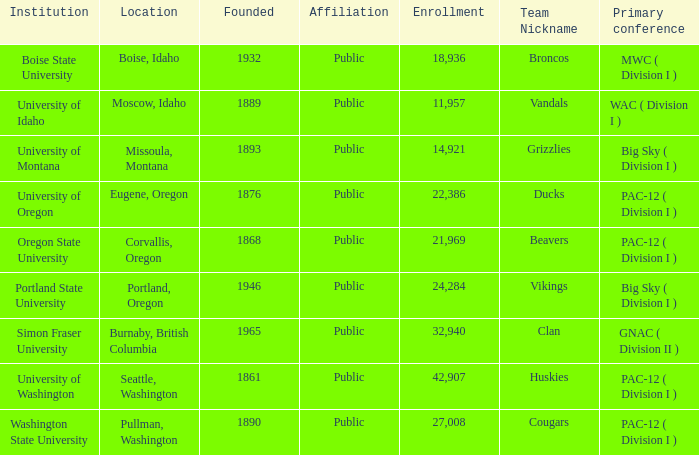What is the location of the team nicknamed Broncos, which was founded after 1889? Boise, Idaho. 